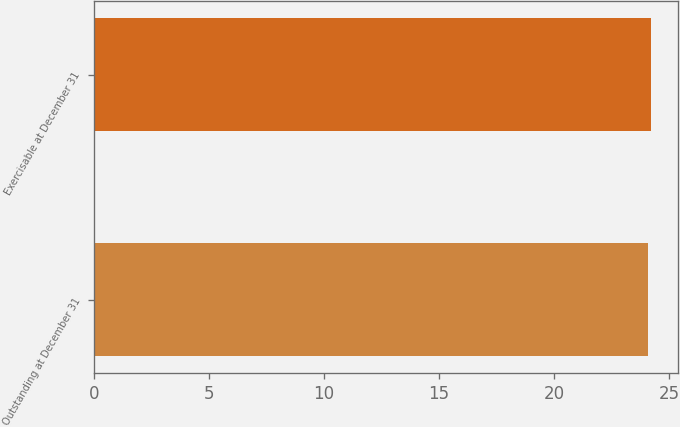<chart> <loc_0><loc_0><loc_500><loc_500><bar_chart><fcel>Outstanding at December 31<fcel>Exercisable at December 31<nl><fcel>24.1<fcel>24.2<nl></chart> 